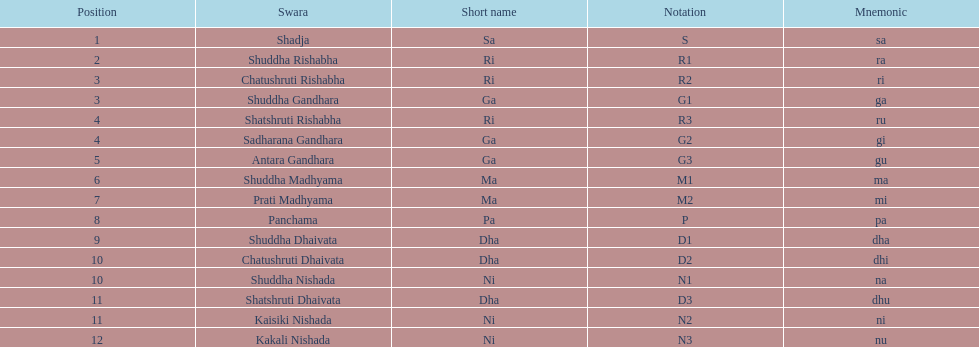Parse the full table. {'header': ['Position', 'Swara', 'Short name', 'Notation', 'Mnemonic'], 'rows': [['1', 'Shadja', 'Sa', 'S', 'sa'], ['2', 'Shuddha Rishabha', 'Ri', 'R1', 'ra'], ['3', 'Chatushruti Rishabha', 'Ri', 'R2', 'ri'], ['3', 'Shuddha Gandhara', 'Ga', 'G1', 'ga'], ['4', 'Shatshruti Rishabha', 'Ri', 'R3', 'ru'], ['4', 'Sadharana Gandhara', 'Ga', 'G2', 'gi'], ['5', 'Antara Gandhara', 'Ga', 'G3', 'gu'], ['6', 'Shuddha Madhyama', 'Ma', 'M1', 'ma'], ['7', 'Prati Madhyama', 'Ma', 'M2', 'mi'], ['8', 'Panchama', 'Pa', 'P', 'pa'], ['9', 'Shuddha Dhaivata', 'Dha', 'D1', 'dha'], ['10', 'Chatushruti Dhaivata', 'Dha', 'D2', 'dhi'], ['10', 'Shuddha Nishada', 'Ni', 'N1', 'na'], ['11', 'Shatshruti Dhaivata', 'Dha', 'D3', 'dhu'], ['11', 'Kaisiki Nishada', 'Ni', 'N2', 'ni'], ['12', 'Kakali Nishada', 'Ni', 'N3', 'nu']]} On average how many of the swara have a short name that begin with d or g? 6. 